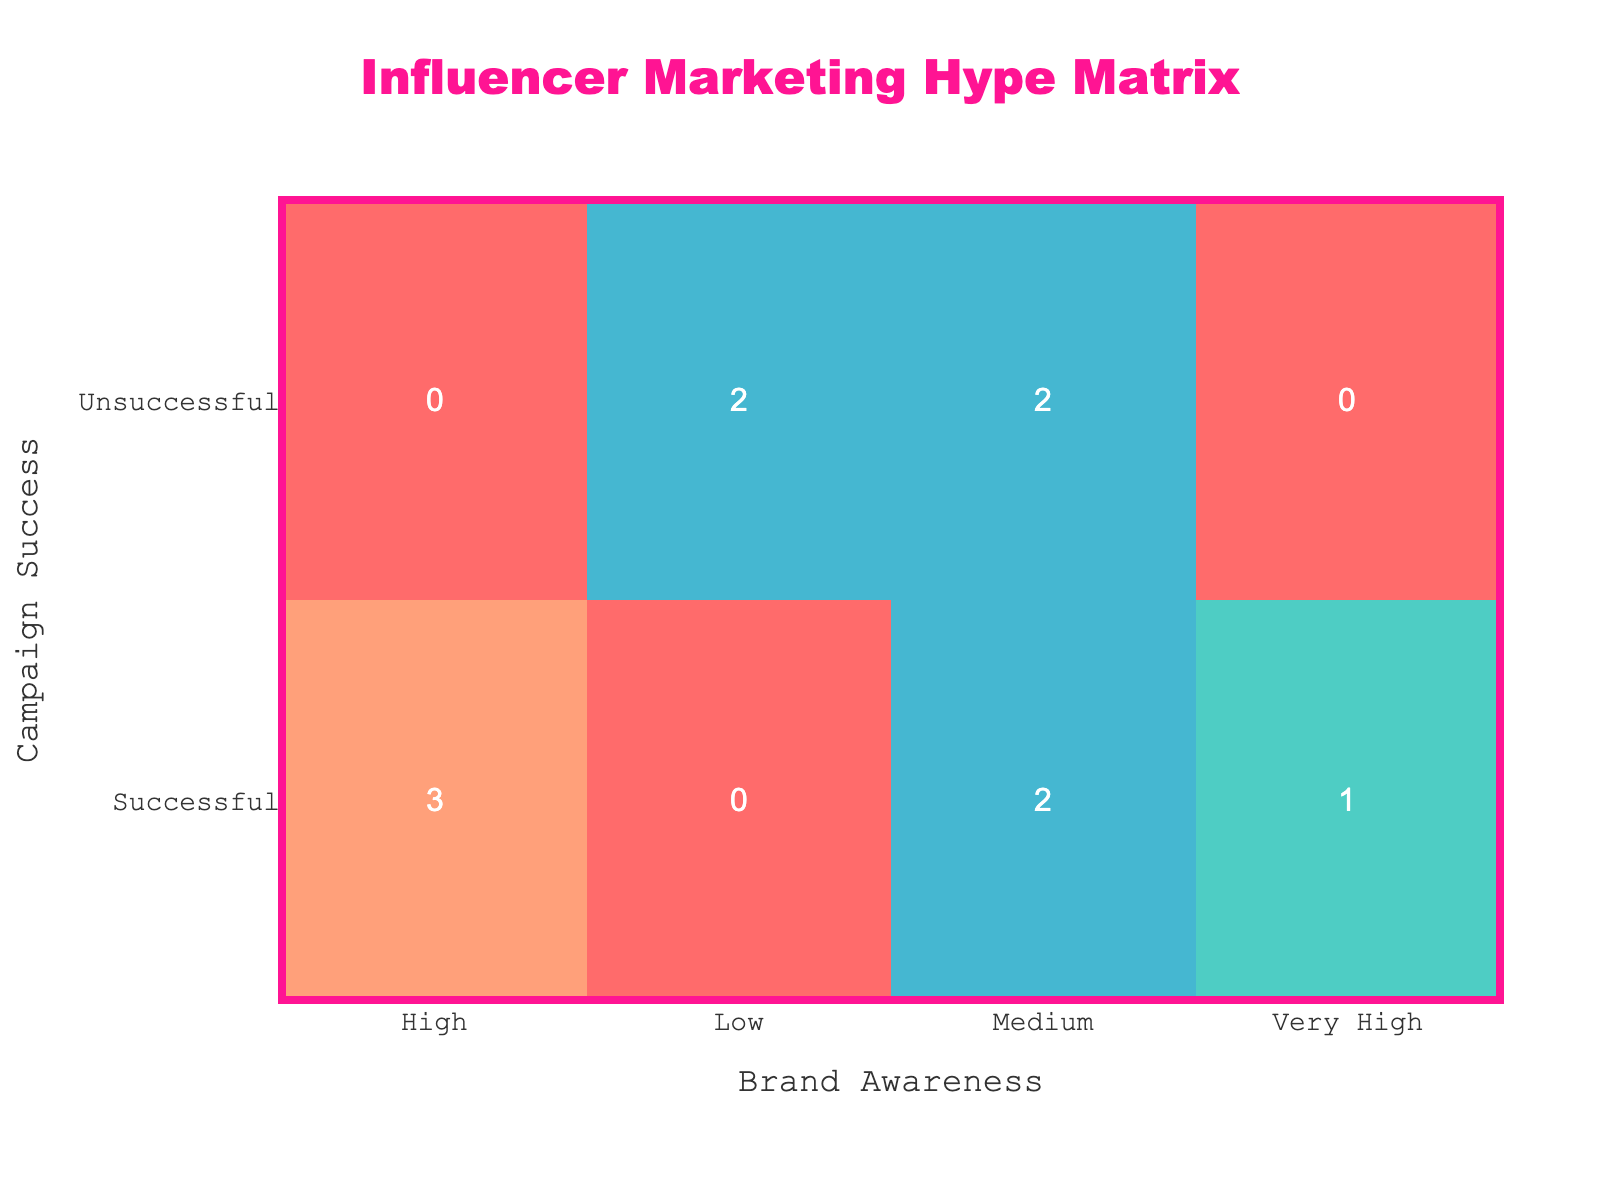What is the total number of successful campaigns? In the table, we look for instances where "Campaign_Success" is labeled as "Successful." Counting these entries gives us 6 successful campaigns: Kylie Jenner, David Dobrik, Lele Pons, Jacksepticeye, MrBeast, and Addison Rae.
Answer: 6 How many influencers generated high brand awareness? We count the number of influencers under the "Brand_Awareness" label of "High." In the table, three influencers—Kylie Jenner, Lele Pons, and Jacksepticeye—achieved High brand awareness.
Answer: 3 Did any unsuccessful campaigns lead to very high brand awareness? We check the table for any instance where "Campaign_Success" is "Unsuccessful" and if that aligns with "Brand_Awareness" being "Very High." There are no such entries, confirming that no unsuccessful campaigns resulted in very high brand awareness.
Answer: No What is the relationship between successful campaigns and brand awareness levels? Analyzing the table, the successful campaigns lead to "High," "Medium," or "Very High" levels of brand awareness, with no successful campaigns resulting in "Low" brand awareness. This shows that successful campaigns generally achieve better awareness levels.
Answer: Successful campaigns correlate with higher brand awareness How many influencers had unsuccessful campaigns that resulted in medium brand awareness? We look for entries where "Campaign_Success" is "Unsuccessful" and "Brand_Awareness" is "Medium." The table shows that there are 2 such influencers, James Charles and Zoe Sugg.
Answer: 2 What percentage of successful campaigns achieved high or very high brand awareness? We identify successful campaigns: 6 in total. Among these, 4 campaigns (Kylie Jenner, Lele Pons, Jacksepticeye, MrBeast) achieved either high or very high awareness. To find the percentage, we calculate (4/6) * 100 = 66.67%.
Answer: 66.67% Is it true that all influencers with low brand awareness had unsuccessful campaigns? We analyze the table for influencers with "Low" brand awareness and find that both NikkieTutorials and Charli D'Amelio fall under "Unsuccessful" campaigns. Therefore, the statement is true since they belong exclusively to this category.
Answer: Yes How many brand awareness categories are present in the table? We list unique values under the "Brand_Awareness" column: Low, Medium, High, and Very High. These four distinct categories indicate the levels of brand awareness presented in the table.
Answer: 4 Which influencer had the highest brand awareness, and what was their campaign success status? A scan of the "Brand_Awareness" column reveals MrBeast, who achieved a status of "Very High". His campaign success status is labeled as "Successful," which shows a strong correlation between the two aspects.
Answer: MrBeast, Successful 